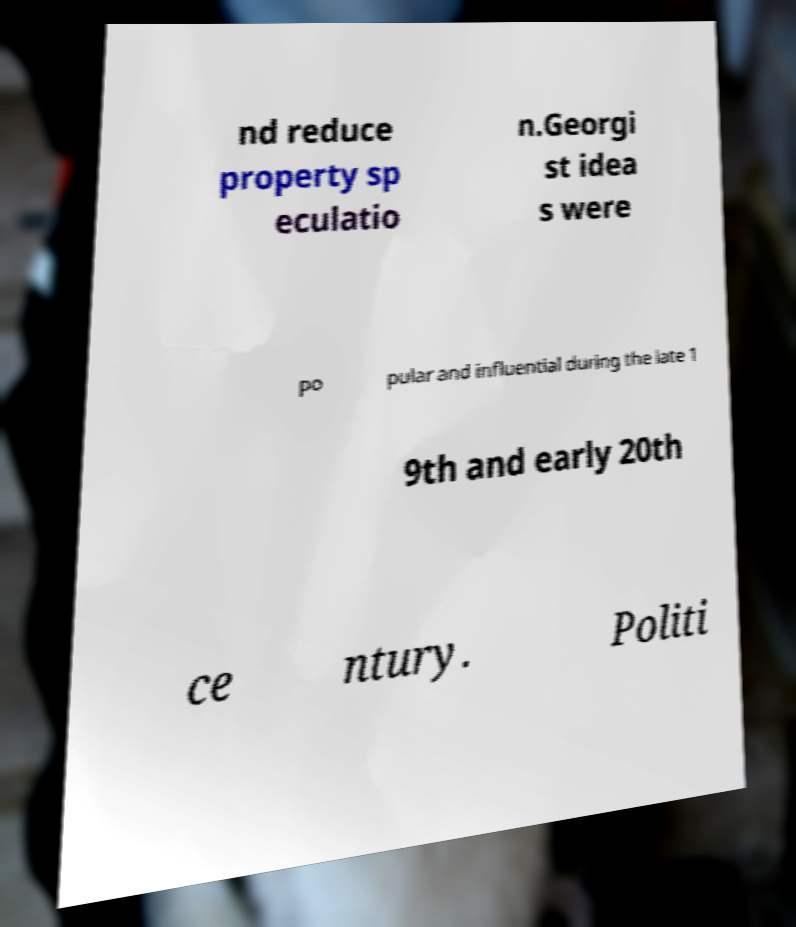Please identify and transcribe the text found in this image. nd reduce property sp eculatio n.Georgi st idea s were po pular and influential during the late 1 9th and early 20th ce ntury. Politi 